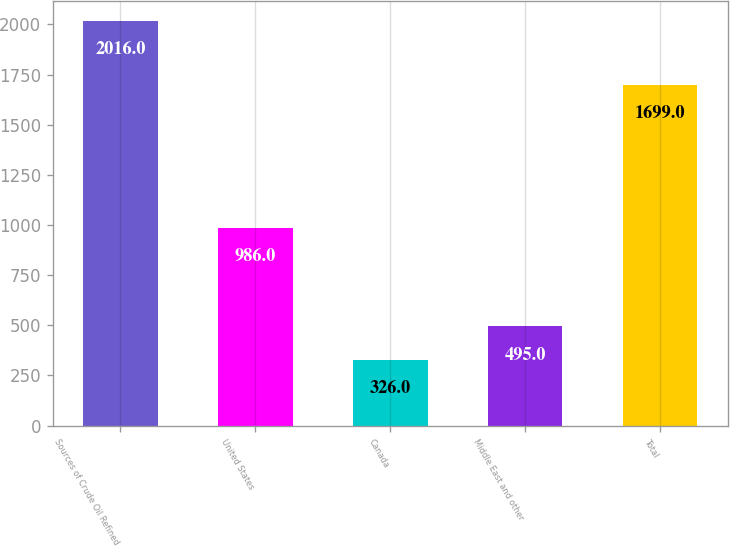Convert chart. <chart><loc_0><loc_0><loc_500><loc_500><bar_chart><fcel>Sources of Crude Oil Refined<fcel>United States<fcel>Canada<fcel>Middle East and other<fcel>Total<nl><fcel>2016<fcel>986<fcel>326<fcel>495<fcel>1699<nl></chart> 